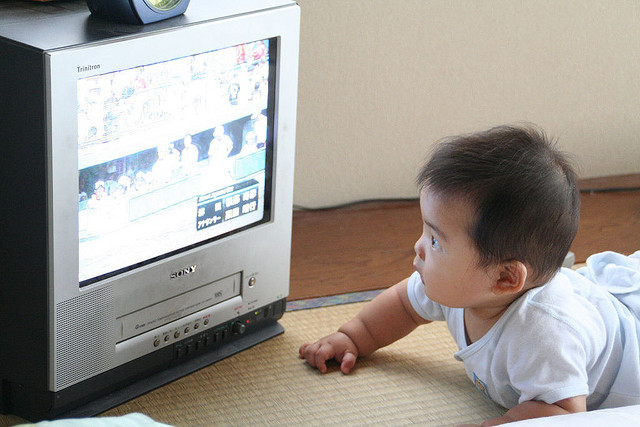Please extract the text content from this image. SONY 